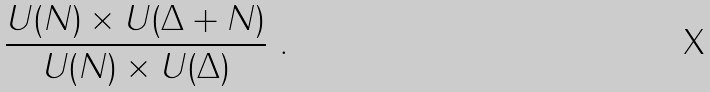Convert formula to latex. <formula><loc_0><loc_0><loc_500><loc_500>\frac { U ( N ) \times U ( \Delta + N ) } { U ( N ) \times U ( \Delta ) } \ .</formula> 